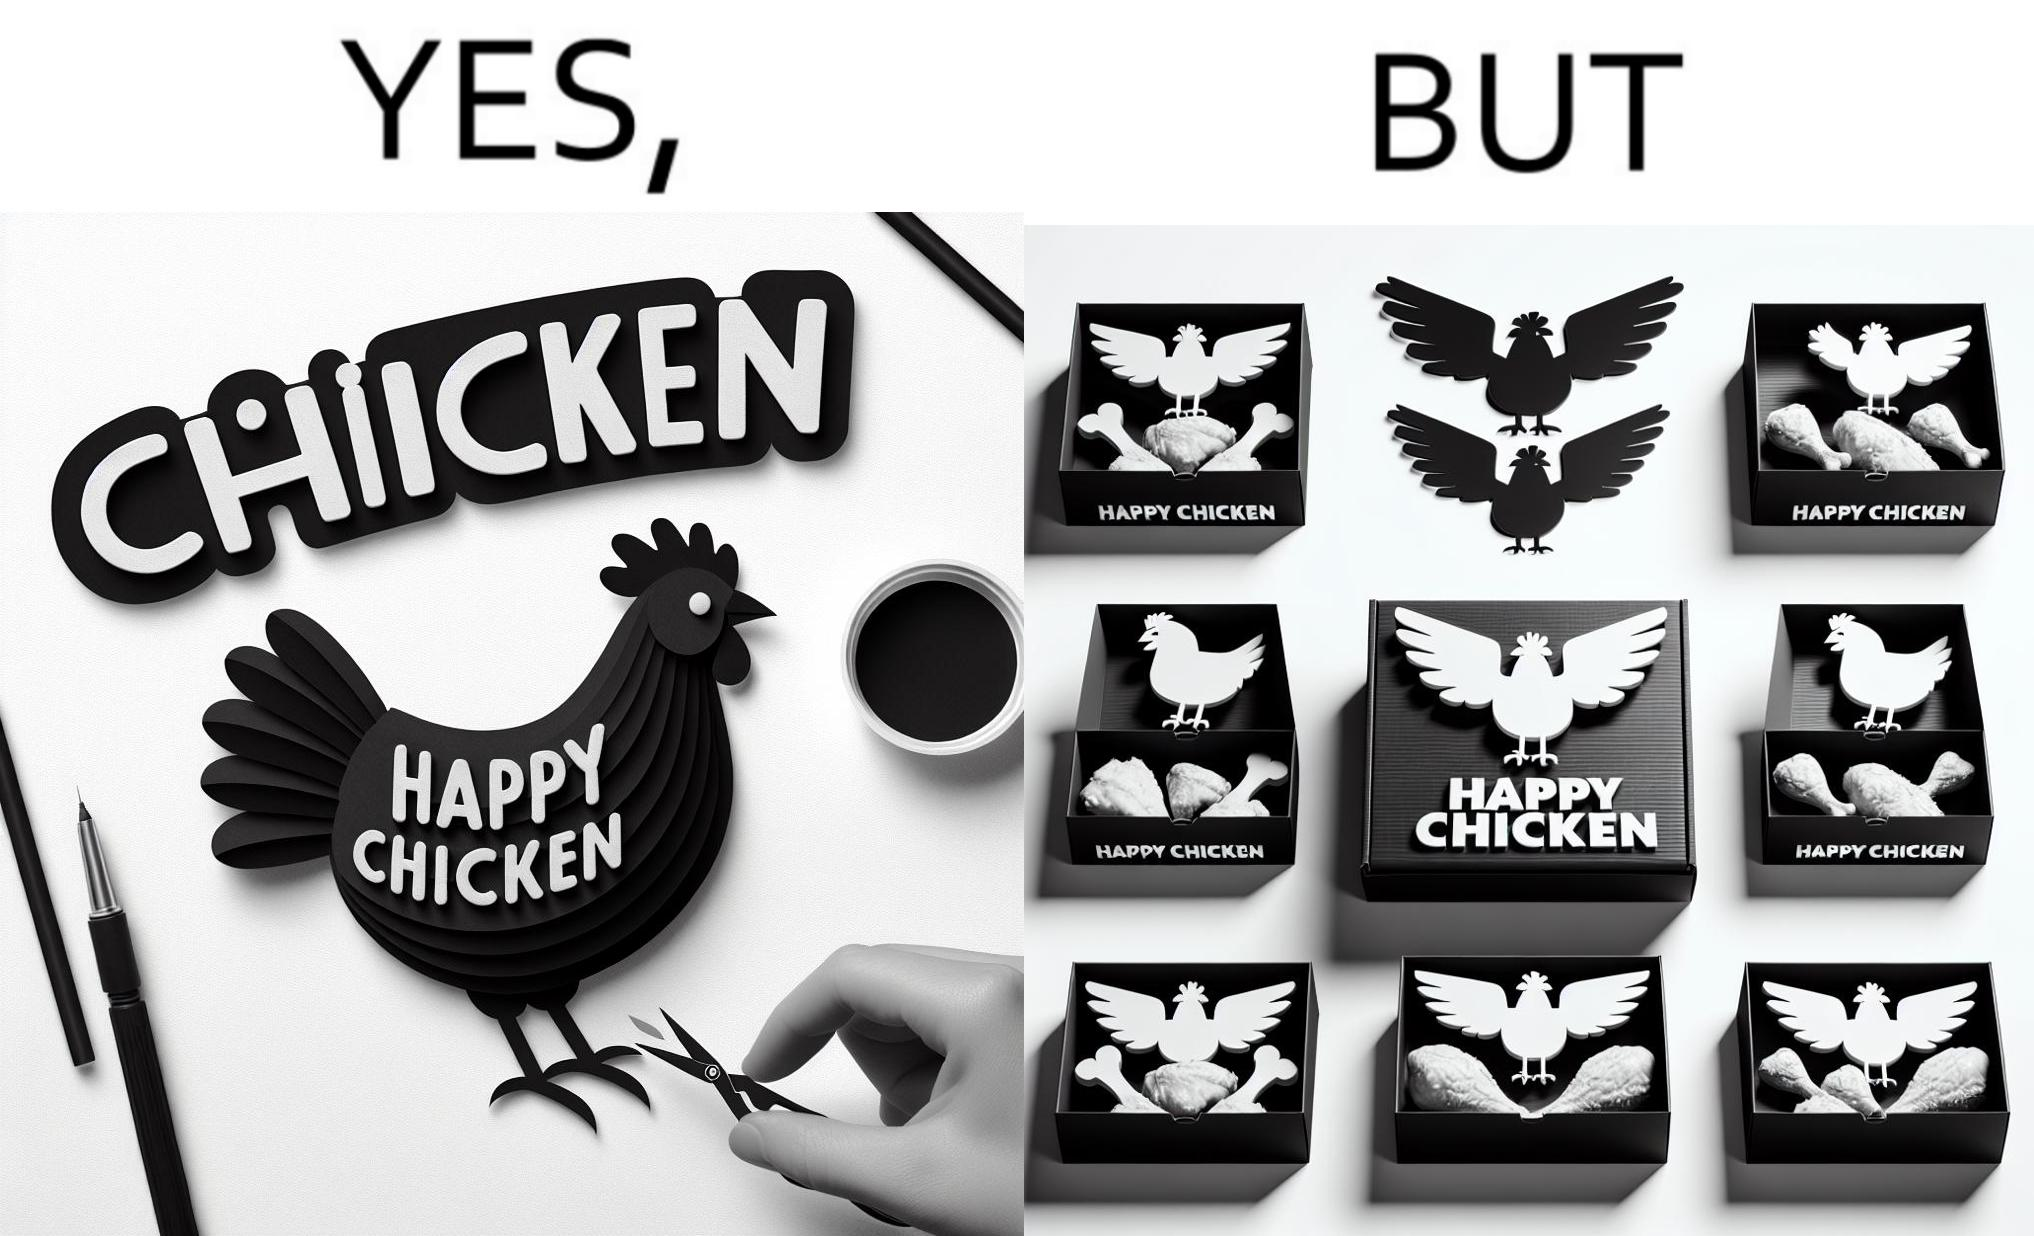Is this image satirical or non-satirical? Yes, this image is satirical. 